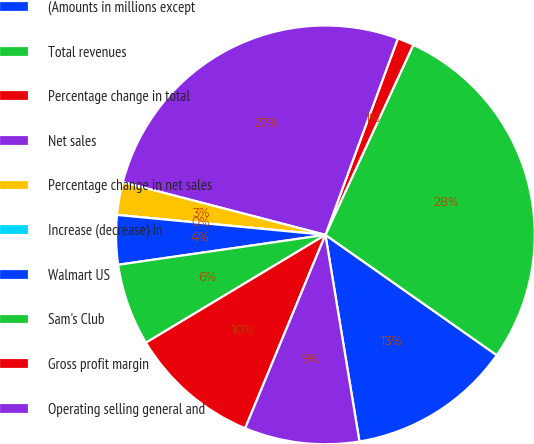<chart> <loc_0><loc_0><loc_500><loc_500><pie_chart><fcel>(Amounts in millions except<fcel>Total revenues<fcel>Percentage change in total<fcel>Net sales<fcel>Percentage change in net sales<fcel>Increase (decrease) in<fcel>Walmart US<fcel>Sam's Club<fcel>Gross profit margin<fcel>Operating selling general and<nl><fcel>12.66%<fcel>27.85%<fcel>1.27%<fcel>26.58%<fcel>2.53%<fcel>0.0%<fcel>3.8%<fcel>6.33%<fcel>10.13%<fcel>8.86%<nl></chart> 